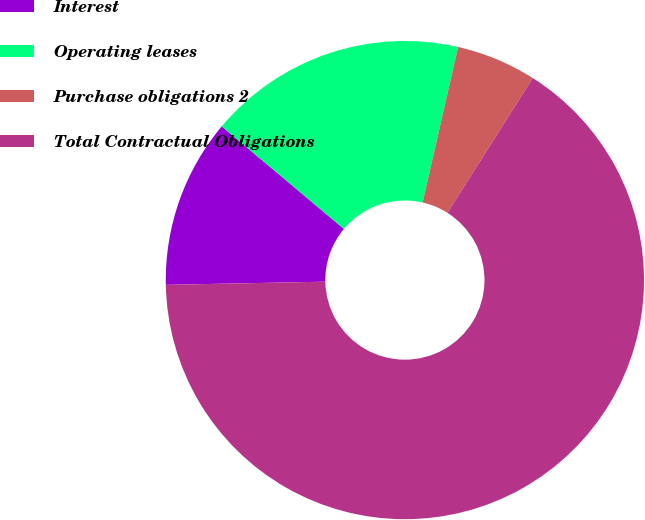Convert chart to OTSL. <chart><loc_0><loc_0><loc_500><loc_500><pie_chart><fcel>Interest<fcel>Operating leases<fcel>Purchase obligations 2<fcel>Total Contractual Obligations<nl><fcel>11.43%<fcel>17.46%<fcel>5.41%<fcel>65.7%<nl></chart> 